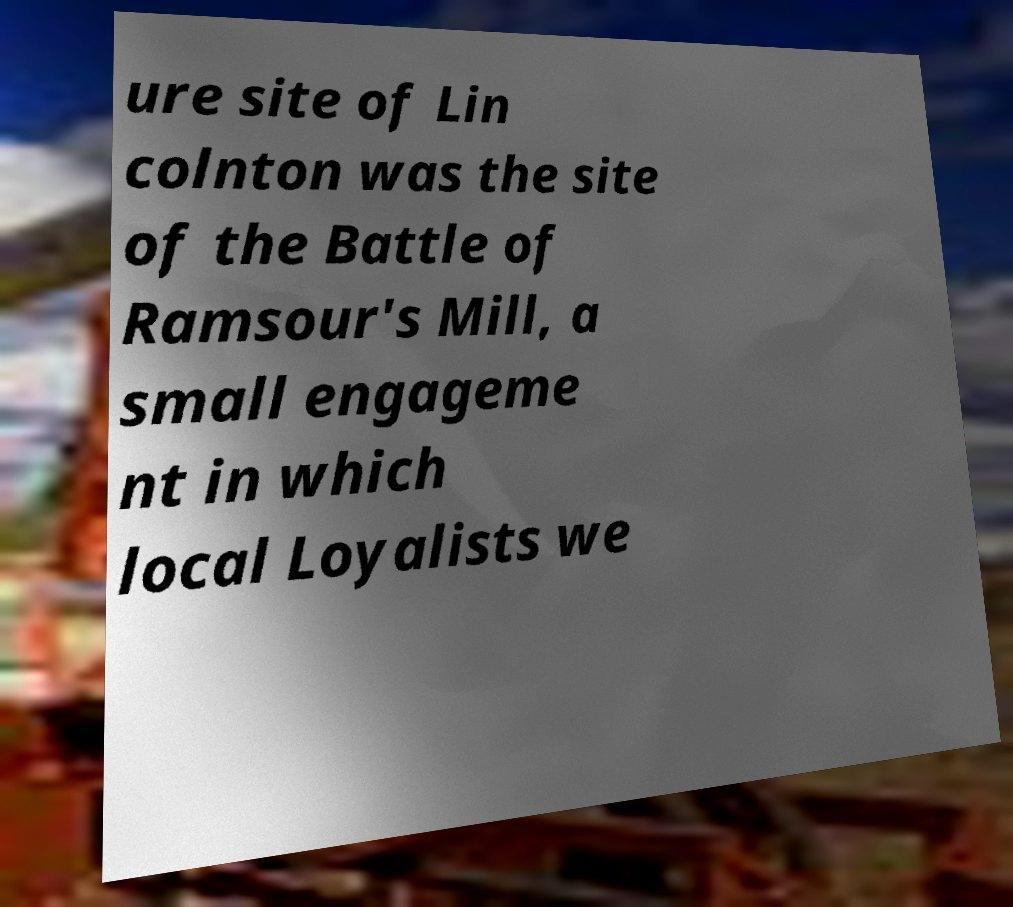Could you extract and type out the text from this image? ure site of Lin colnton was the site of the Battle of Ramsour's Mill, a small engageme nt in which local Loyalists we 